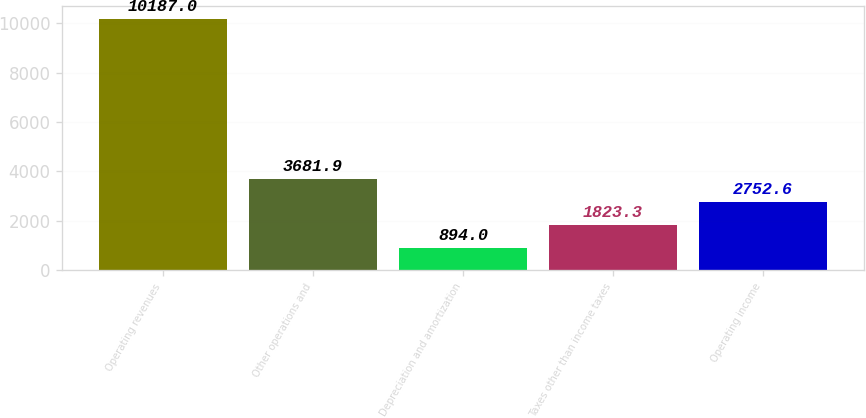Convert chart to OTSL. <chart><loc_0><loc_0><loc_500><loc_500><bar_chart><fcel>Operating revenues<fcel>Other operations and<fcel>Depreciation and amortization<fcel>Taxes other than income taxes<fcel>Operating income<nl><fcel>10187<fcel>3681.9<fcel>894<fcel>1823.3<fcel>2752.6<nl></chart> 